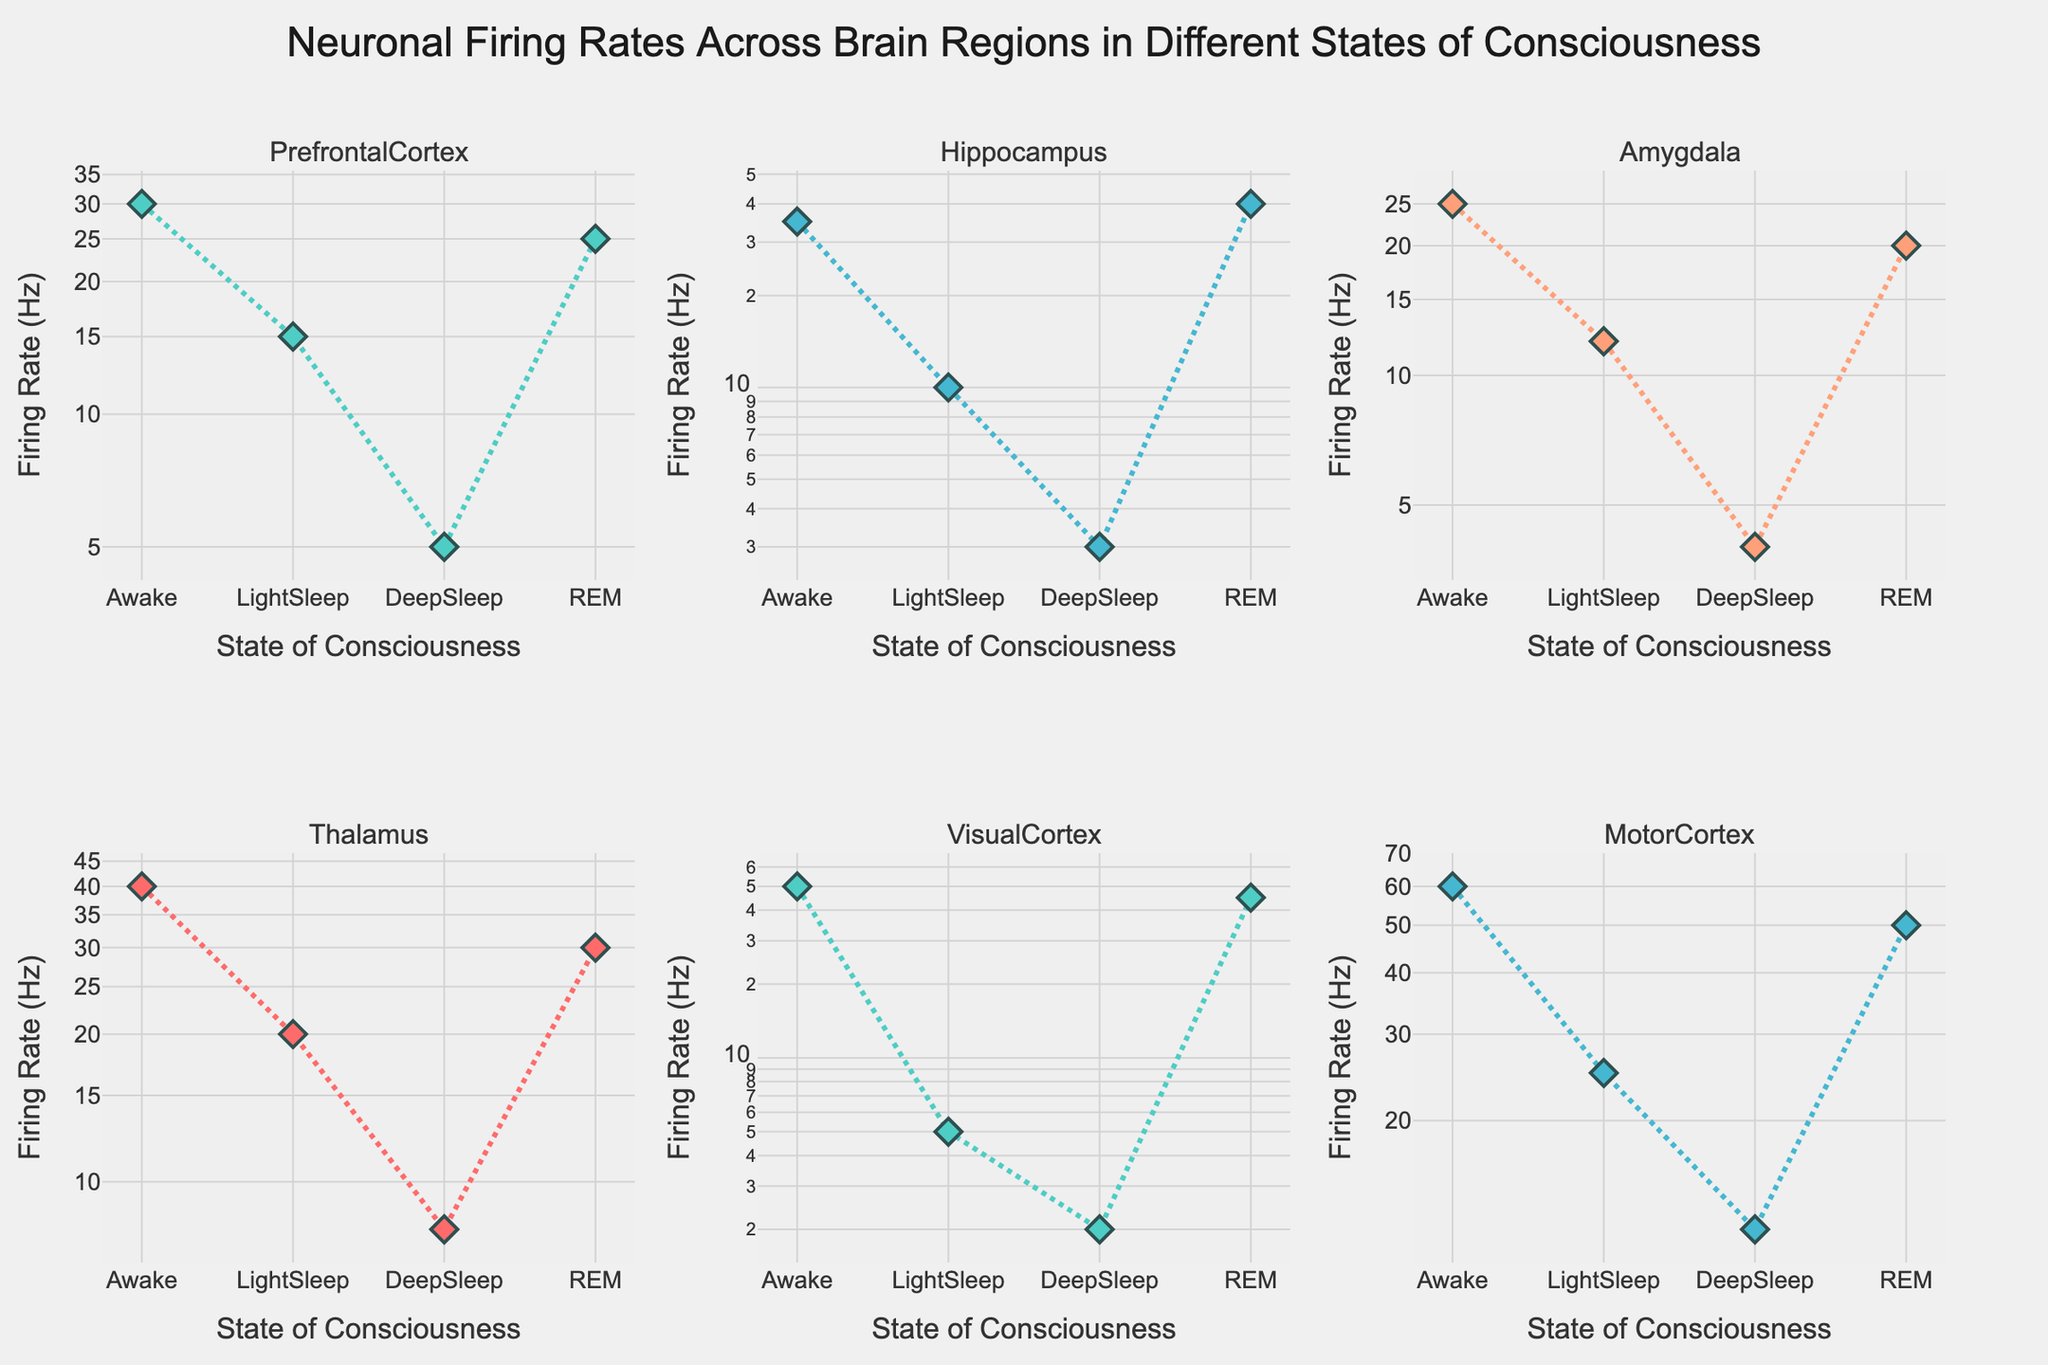What's the title of the figure? The title of the figure is generally displayed at the top. By looking at the figure, the visible text at the top is the title.
Answer: Neuronal Firing Rates Across Brain Regions in Different States of Consciousness How many brain regions are analyzed in the figure? The figure divides the data into subplots, each representing a different brain region. By counting the number of subplots, we can determine the number of brain regions analyzed.
Answer: 6 What is the firing rate in the Prefrontal Cortex during REM sleep? Look at the subplot for the Prefrontal Cortex and observe the data point corresponding to REM sleep. The y-axis value of this point shows the firing rate.
Answer: 25 Hz Which brain region has the lowest firing rate during Deep Sleep? Compare the firing rates during Deep Sleep across all subplots. Identify the lowest value among these.
Answer: Visual Cortex What is the difference in firing rate between the Visual Cortex and the Amygdala during Awake state? Determine the firing rate of the Visual Cortex and the Amygdala during the Awake state, then calculate the difference by subtracting the Amygdala's rate from the Visual Cortex's rate.
Answer: 25 Hz Which brain region shows the highest increase in firing rate from Deep Sleep to REM sleep? For each brain region subplot, calculate the increase in firing rate from Deep Sleep to REM sleep. Identify which has the greatest increase.
Answer: Hippocampus In which brain region is the firing rate lowest during Light Sleep? Examine the subplot for each brain region and identify the firing rate values during Light Sleep. The minimum value among these subplots will be the lowest.
Answer: Visual Cortex How does the firing rate in the Thalamus compare between Awake and REM states? Look at the Thalamus subplot to compare the firing rates during the Awake and REM states. Identify which state has a higher value or if they are equal.
Answer: Awake > REM Which state of consciousness exhibits the most consistent firing rates across all brain regions? Compare the variation in firing rates across all brain regions for each state of consciousness. The state with the smallest range (difference between highest and lowest rate) exhibits the most consistency.
Answer: Light Sleep What is the ratio of firing rates in the Motor Cortex between Awake and Deep Sleep states? Identify the firing rates of the Motor Cortex during the Awake and Deep Sleep states, then divide the Awake state firing rate by the Deep Sleep state firing rate to obtain the ratio.
Answer: 5 